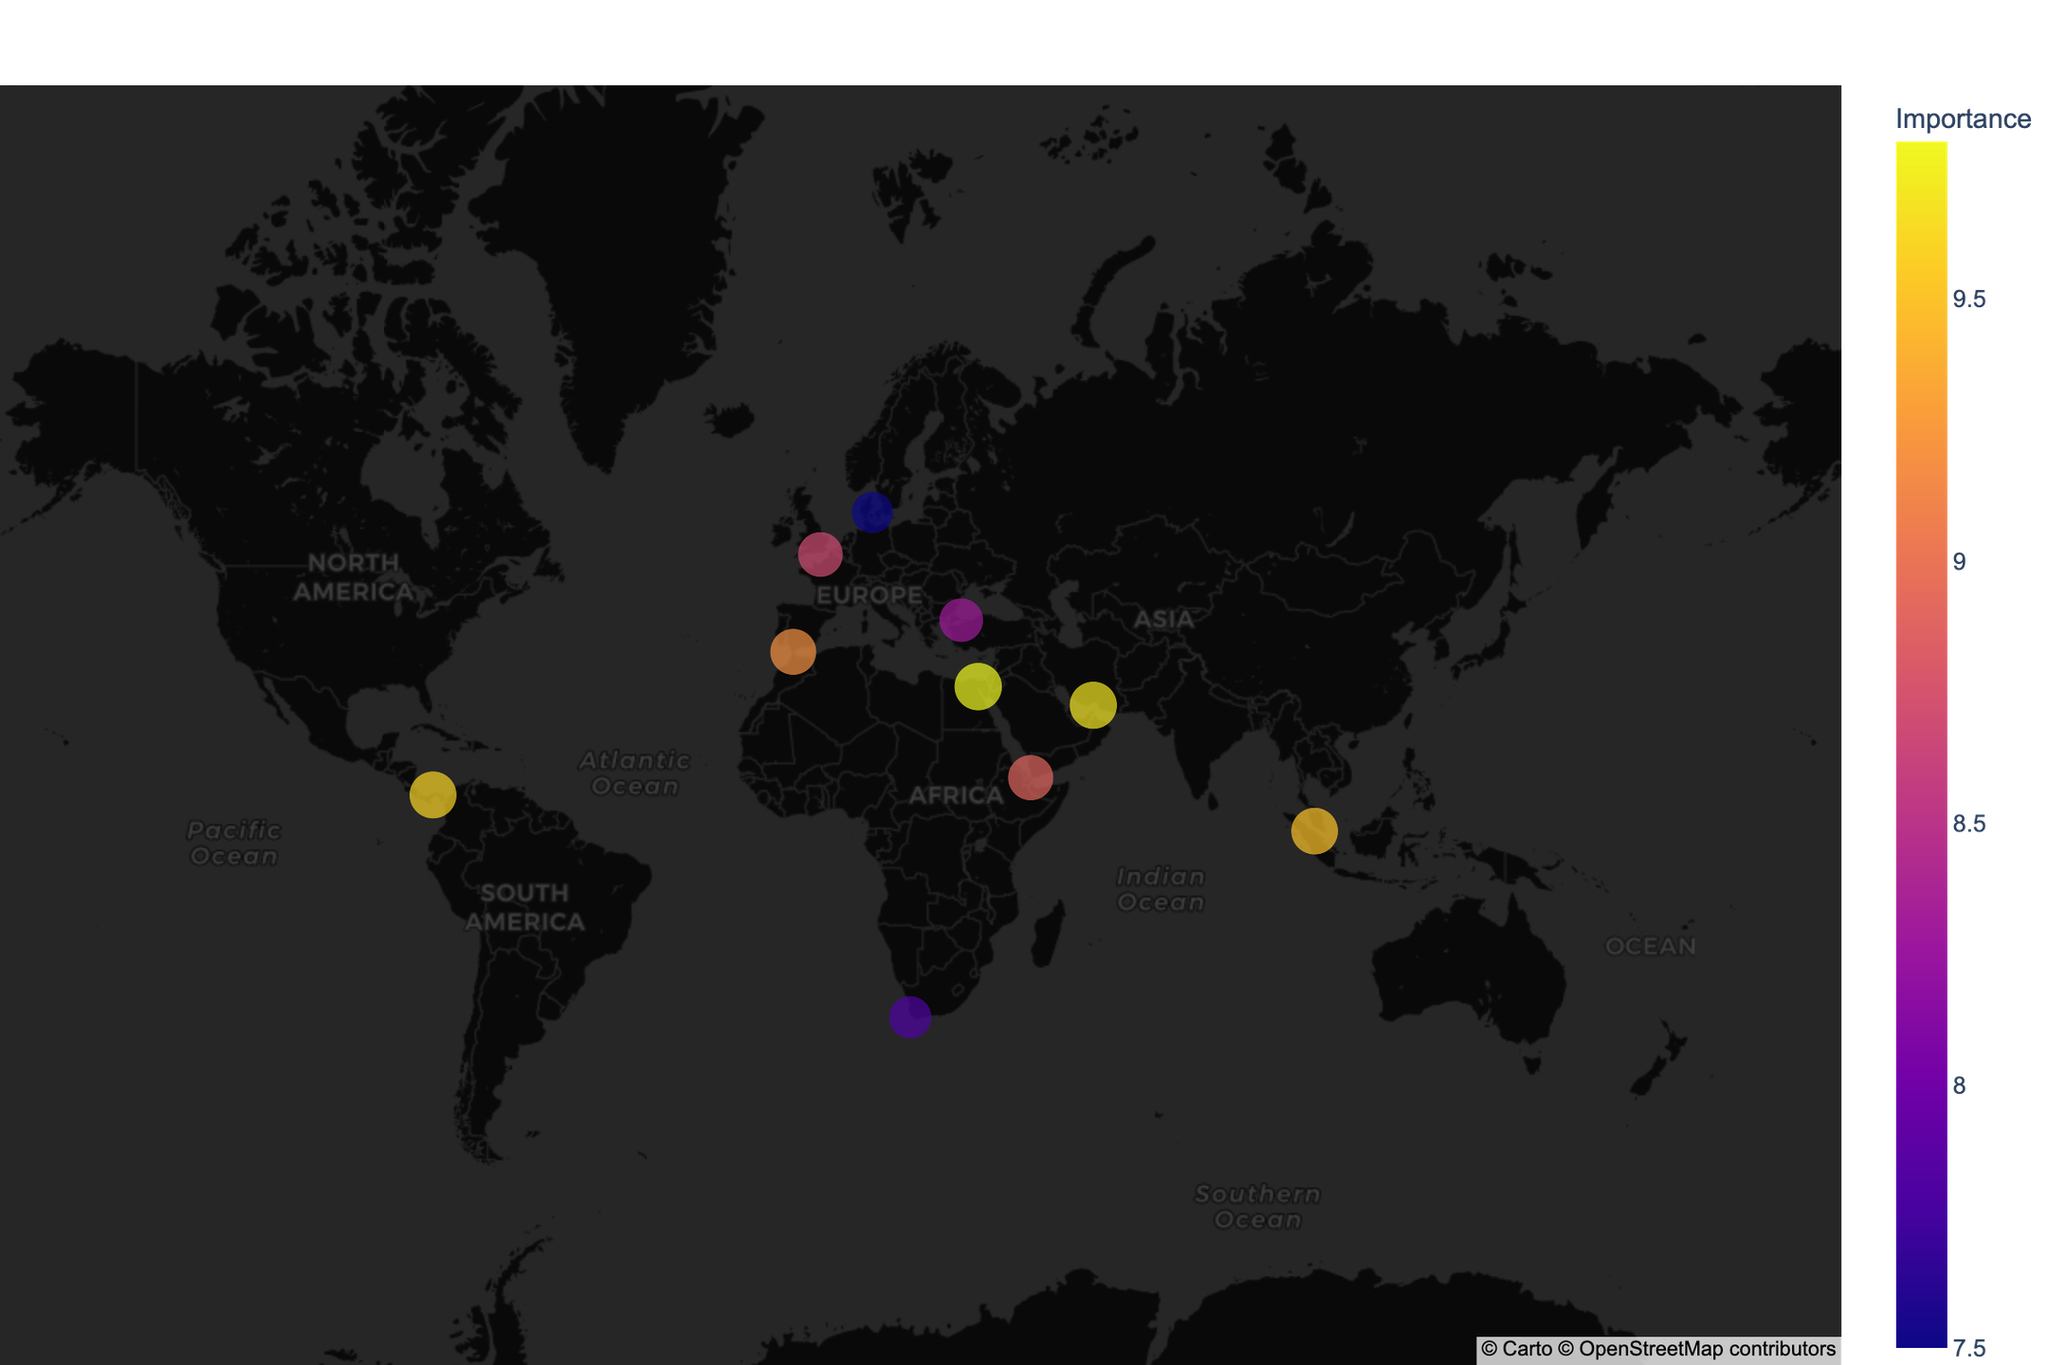What's the main title of the plot? The main title of the plot is usually prominently displayed at the top center. In this case, it is "Strategic Chokepoints and Maritime Trade Routes".
Answer: Strategic Chokepoints and Maritime Trade Routes What type of chokepoint has the highest Importance value? To answer this, we look at the data points on the map that denote Importance. The Suez Canal, an Artificial Waterway, has the highest Importance value of 9.8.
Answer: Artificial Waterway Which locations are depicted in terms of historical access to major seas? The areas of historical significance tied to sea access include the Bab el-Mandeb for Red Sea access, the Gibraltar Strait for Mediterranean access, and the Danish Straits for Baltic Sea access.
Answer: Bab el-Mandeb, Gibraltar Strait, Danish Straits How many Maritime Chokepoints are on the map? Maritime Chokepoints are noted as the 'Type' in the hover information. The locations are Strait of Malacca, Strait of Hormuz, Bab el-Mandeb, Gibraltar Strait, Bosphorus Strait, and Danish Straits, making a total of six.
Answer: 6 Which trading route has the lowest Importance value and what is its historical significance? To determine this, we identify the trading route with the lowest Importance. The Danish Straits have the lowest Importance value of 7.5, and its historical significance is access to the Baltic Sea.
Answer: Danish Straits, Baltic Sea access Which maritime trade routes connect different oceans and seas? By examining the locations with detailed descriptions, the Panama Canal connects the Atlantic and Pacific Oceans, and the Suez Canal is a shortcut between Europe and Asia.
Answer: Panama Canal, Suez Canal Between the Strait of Malacca and the Strait of Hormuz, which location has a higher Importance and by how much? The Importance values for the Strait of Malacca is 9.5 and for the Strait of Hormuz is 9.7. The Strait of Hormuz has a higher Importance by 0.2.
Answer: Strait of Hormuz, 0.2 What is the color representing the highest Importance value and which location does it correspond to? The color scale on the map is sequential. The brightest color, indicating the highest Importance value, corresponds to the Suez Canal.
Answer: Suez Canal 